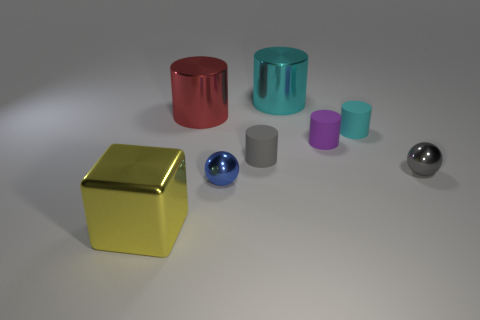There is another shiny thing that is the same size as the blue metallic thing; what shape is it?
Keep it short and to the point. Sphere. What is the size of the cyan metallic thing?
Your response must be concise. Large. Is the purple object made of the same material as the small cyan cylinder?
Provide a short and direct response. Yes. What number of cyan metallic cylinders are behind the metal cylinder that is on the left side of the big cylinder behind the red metallic thing?
Make the answer very short. 1. What shape is the large object that is in front of the red metallic object?
Your answer should be compact. Cube. How many other things are made of the same material as the tiny blue ball?
Your answer should be compact. 4. Is the number of tiny purple things on the left side of the large red cylinder less than the number of large things behind the tiny cyan matte thing?
Keep it short and to the point. Yes. What is the color of the other shiny thing that is the same shape as the tiny blue thing?
Offer a terse response. Gray. Does the rubber cylinder that is on the right side of the purple cylinder have the same size as the yellow metal cube?
Offer a very short reply. No. Is the number of small things in front of the small gray metallic object less than the number of balls?
Make the answer very short. Yes. 